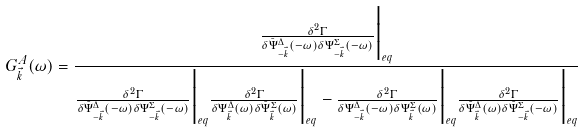<formula> <loc_0><loc_0><loc_500><loc_500>G ^ { A } _ { \vec { k } } ( \omega ) = \frac { \frac { \delta ^ { 2 } \Gamma } { \delta \bar { \Psi } _ { - \vec { k } } ^ { \Delta } ( - \omega ) \delta \Psi _ { - \vec { k } } ^ { \Sigma } ( - \omega ) } \Big | _ { e q } } { \frac { \delta ^ { 2 } \Gamma } { \delta \bar { \Psi } _ { - \vec { k } } ^ { \Delta } ( - \omega ) \delta \Psi _ { - \vec { k } } ^ { \Sigma } ( - \omega ) } \Big | _ { e q } \frac { \delta ^ { 2 } \Gamma } { \delta \Psi _ { \vec { k } } ^ { \Delta } ( \omega ) \delta \bar { \Psi } _ { \vec { k } } ^ { \Sigma } ( \omega ) } \Big | _ { e q } - \frac { \delta ^ { 2 } \Gamma } { \delta \Psi _ { - \vec { k } } ^ { \Delta } ( - \omega ) \delta \Psi _ { \vec { k } } ^ { \Sigma } ( \omega ) } \Big | _ { e q } \frac { \delta ^ { 2 } \Gamma } { \delta \bar { \Psi } _ { \vec { k } } ^ { \Delta } ( \omega ) \delta \bar { \Psi } _ { - \vec { k } } ^ { \Sigma } ( - \omega ) } \Big | _ { e q } }</formula> 